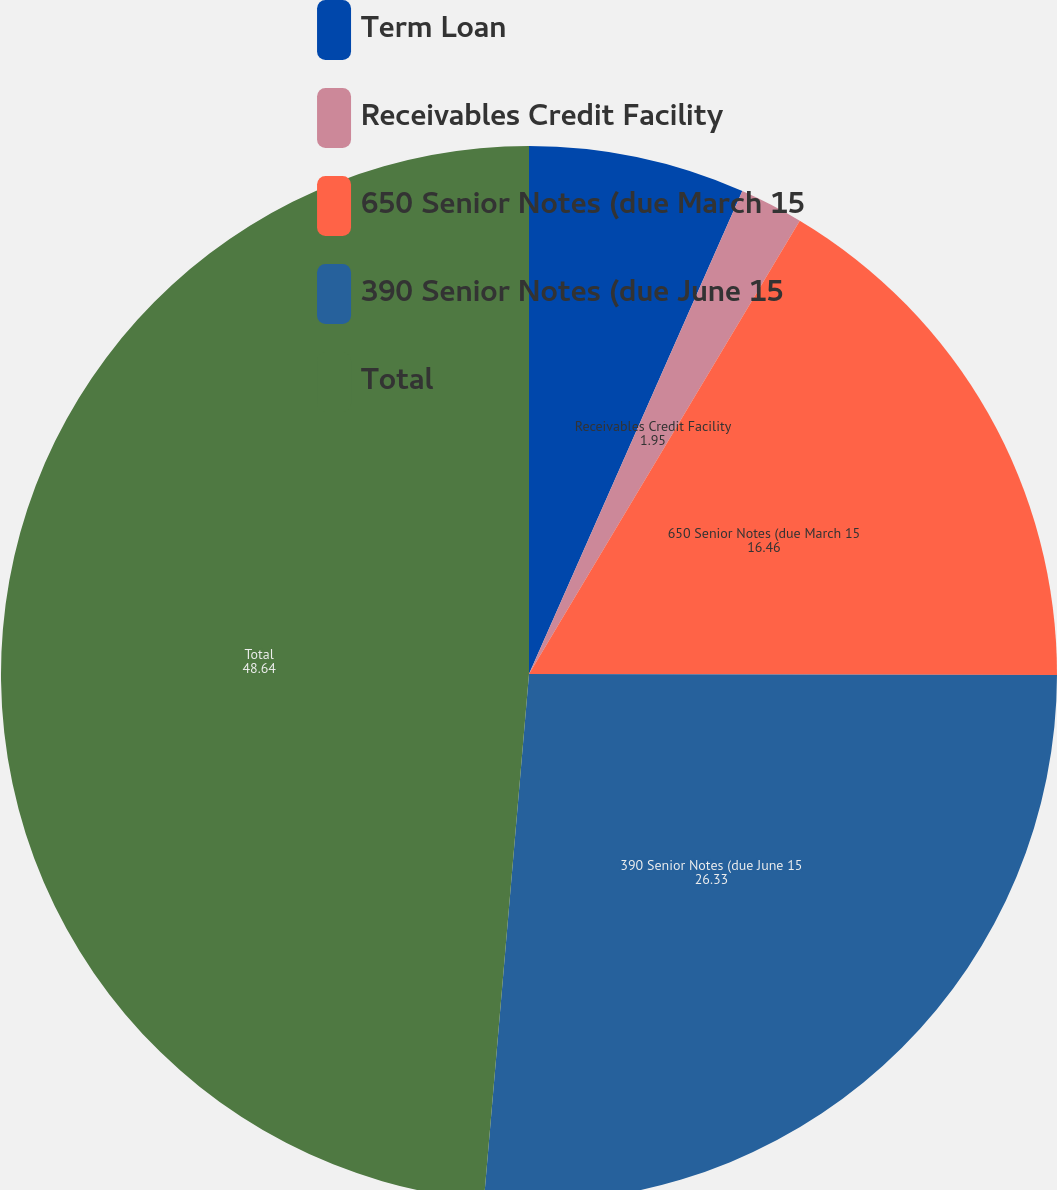Convert chart. <chart><loc_0><loc_0><loc_500><loc_500><pie_chart><fcel>Term Loan<fcel>Receivables Credit Facility<fcel>650 Senior Notes (due March 15<fcel>390 Senior Notes (due June 15<fcel>Total<nl><fcel>6.62%<fcel>1.95%<fcel>16.46%<fcel>26.33%<fcel>48.64%<nl></chart> 